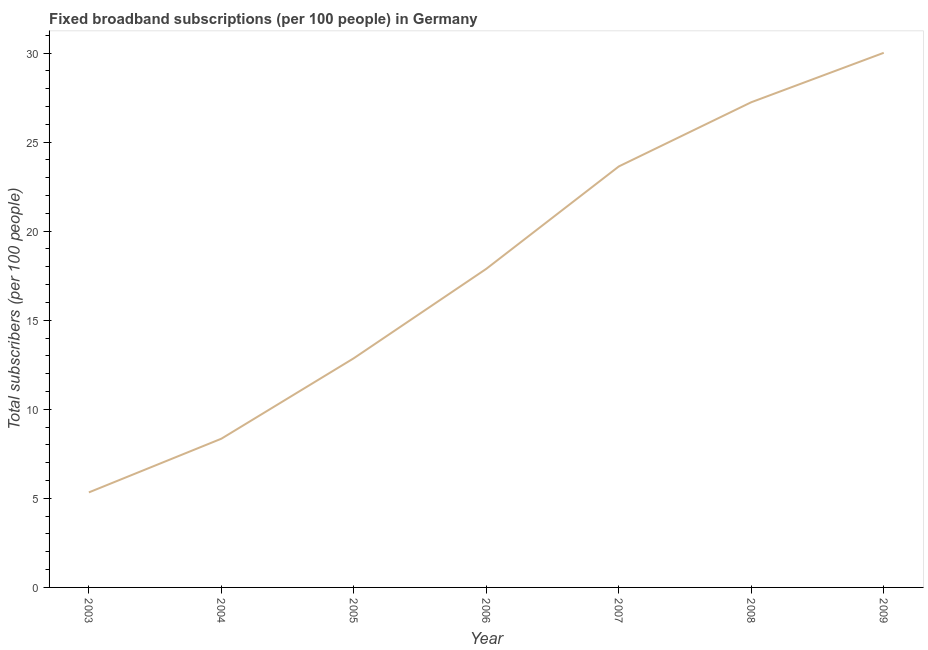What is the total number of fixed broadband subscriptions in 2007?
Provide a succinct answer. 23.63. Across all years, what is the maximum total number of fixed broadband subscriptions?
Your answer should be very brief. 30.01. Across all years, what is the minimum total number of fixed broadband subscriptions?
Ensure brevity in your answer.  5.33. In which year was the total number of fixed broadband subscriptions maximum?
Provide a succinct answer. 2009. In which year was the total number of fixed broadband subscriptions minimum?
Your answer should be compact. 2003. What is the sum of the total number of fixed broadband subscriptions?
Give a very brief answer. 125.32. What is the difference between the total number of fixed broadband subscriptions in 2004 and 2009?
Your answer should be compact. -21.66. What is the average total number of fixed broadband subscriptions per year?
Make the answer very short. 17.9. What is the median total number of fixed broadband subscriptions?
Your answer should be very brief. 17.89. In how many years, is the total number of fixed broadband subscriptions greater than 26 ?
Your response must be concise. 2. What is the ratio of the total number of fixed broadband subscriptions in 2006 to that in 2007?
Provide a succinct answer. 0.76. What is the difference between the highest and the second highest total number of fixed broadband subscriptions?
Offer a very short reply. 2.77. Is the sum of the total number of fixed broadband subscriptions in 2003 and 2007 greater than the maximum total number of fixed broadband subscriptions across all years?
Provide a succinct answer. No. What is the difference between the highest and the lowest total number of fixed broadband subscriptions?
Your response must be concise. 24.68. In how many years, is the total number of fixed broadband subscriptions greater than the average total number of fixed broadband subscriptions taken over all years?
Offer a terse response. 3. Does the total number of fixed broadband subscriptions monotonically increase over the years?
Keep it short and to the point. Yes. How many lines are there?
Offer a very short reply. 1. Are the values on the major ticks of Y-axis written in scientific E-notation?
Your answer should be very brief. No. Does the graph contain grids?
Provide a succinct answer. No. What is the title of the graph?
Provide a short and direct response. Fixed broadband subscriptions (per 100 people) in Germany. What is the label or title of the Y-axis?
Provide a succinct answer. Total subscribers (per 100 people). What is the Total subscribers (per 100 people) of 2003?
Make the answer very short. 5.33. What is the Total subscribers (per 100 people) in 2004?
Your answer should be compact. 8.35. What is the Total subscribers (per 100 people) of 2005?
Offer a terse response. 12.87. What is the Total subscribers (per 100 people) in 2006?
Offer a very short reply. 17.89. What is the Total subscribers (per 100 people) of 2007?
Offer a very short reply. 23.63. What is the Total subscribers (per 100 people) in 2008?
Provide a short and direct response. 27.24. What is the Total subscribers (per 100 people) of 2009?
Make the answer very short. 30.01. What is the difference between the Total subscribers (per 100 people) in 2003 and 2004?
Ensure brevity in your answer.  -3.01. What is the difference between the Total subscribers (per 100 people) in 2003 and 2005?
Make the answer very short. -7.53. What is the difference between the Total subscribers (per 100 people) in 2003 and 2006?
Your answer should be very brief. -12.55. What is the difference between the Total subscribers (per 100 people) in 2003 and 2007?
Offer a very short reply. -18.3. What is the difference between the Total subscribers (per 100 people) in 2003 and 2008?
Ensure brevity in your answer.  -21.9. What is the difference between the Total subscribers (per 100 people) in 2003 and 2009?
Keep it short and to the point. -24.68. What is the difference between the Total subscribers (per 100 people) in 2004 and 2005?
Your response must be concise. -4.52. What is the difference between the Total subscribers (per 100 people) in 2004 and 2006?
Your answer should be very brief. -9.54. What is the difference between the Total subscribers (per 100 people) in 2004 and 2007?
Make the answer very short. -15.28. What is the difference between the Total subscribers (per 100 people) in 2004 and 2008?
Your answer should be very brief. -18.89. What is the difference between the Total subscribers (per 100 people) in 2004 and 2009?
Your answer should be compact. -21.66. What is the difference between the Total subscribers (per 100 people) in 2005 and 2006?
Give a very brief answer. -5.02. What is the difference between the Total subscribers (per 100 people) in 2005 and 2007?
Provide a succinct answer. -10.77. What is the difference between the Total subscribers (per 100 people) in 2005 and 2008?
Your answer should be compact. -14.37. What is the difference between the Total subscribers (per 100 people) in 2005 and 2009?
Give a very brief answer. -17.15. What is the difference between the Total subscribers (per 100 people) in 2006 and 2007?
Give a very brief answer. -5.75. What is the difference between the Total subscribers (per 100 people) in 2006 and 2008?
Ensure brevity in your answer.  -9.35. What is the difference between the Total subscribers (per 100 people) in 2006 and 2009?
Keep it short and to the point. -12.13. What is the difference between the Total subscribers (per 100 people) in 2007 and 2008?
Provide a succinct answer. -3.6. What is the difference between the Total subscribers (per 100 people) in 2007 and 2009?
Your answer should be very brief. -6.38. What is the difference between the Total subscribers (per 100 people) in 2008 and 2009?
Offer a very short reply. -2.77. What is the ratio of the Total subscribers (per 100 people) in 2003 to that in 2004?
Give a very brief answer. 0.64. What is the ratio of the Total subscribers (per 100 people) in 2003 to that in 2005?
Keep it short and to the point. 0.41. What is the ratio of the Total subscribers (per 100 people) in 2003 to that in 2006?
Offer a terse response. 0.3. What is the ratio of the Total subscribers (per 100 people) in 2003 to that in 2007?
Your answer should be compact. 0.23. What is the ratio of the Total subscribers (per 100 people) in 2003 to that in 2008?
Provide a short and direct response. 0.2. What is the ratio of the Total subscribers (per 100 people) in 2003 to that in 2009?
Your answer should be compact. 0.18. What is the ratio of the Total subscribers (per 100 people) in 2004 to that in 2005?
Make the answer very short. 0.65. What is the ratio of the Total subscribers (per 100 people) in 2004 to that in 2006?
Provide a succinct answer. 0.47. What is the ratio of the Total subscribers (per 100 people) in 2004 to that in 2007?
Offer a very short reply. 0.35. What is the ratio of the Total subscribers (per 100 people) in 2004 to that in 2008?
Give a very brief answer. 0.31. What is the ratio of the Total subscribers (per 100 people) in 2004 to that in 2009?
Your response must be concise. 0.28. What is the ratio of the Total subscribers (per 100 people) in 2005 to that in 2006?
Offer a terse response. 0.72. What is the ratio of the Total subscribers (per 100 people) in 2005 to that in 2007?
Provide a short and direct response. 0.54. What is the ratio of the Total subscribers (per 100 people) in 2005 to that in 2008?
Provide a short and direct response. 0.47. What is the ratio of the Total subscribers (per 100 people) in 2005 to that in 2009?
Offer a very short reply. 0.43. What is the ratio of the Total subscribers (per 100 people) in 2006 to that in 2007?
Provide a succinct answer. 0.76. What is the ratio of the Total subscribers (per 100 people) in 2006 to that in 2008?
Make the answer very short. 0.66. What is the ratio of the Total subscribers (per 100 people) in 2006 to that in 2009?
Keep it short and to the point. 0.6. What is the ratio of the Total subscribers (per 100 people) in 2007 to that in 2008?
Your answer should be compact. 0.87. What is the ratio of the Total subscribers (per 100 people) in 2007 to that in 2009?
Make the answer very short. 0.79. What is the ratio of the Total subscribers (per 100 people) in 2008 to that in 2009?
Give a very brief answer. 0.91. 